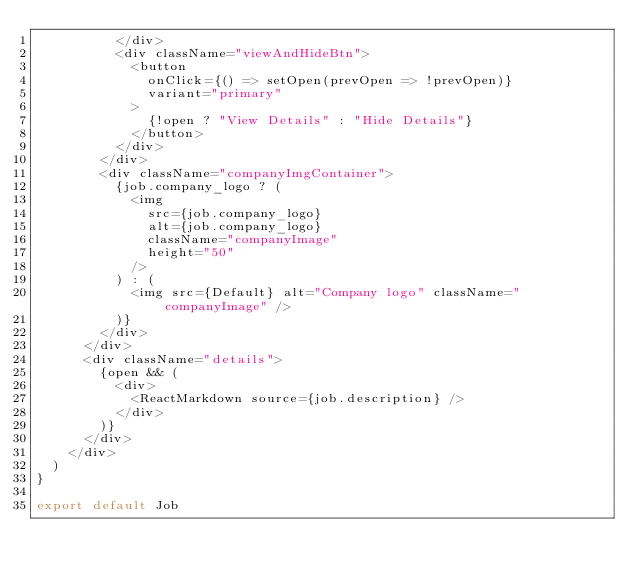Convert code to text. <code><loc_0><loc_0><loc_500><loc_500><_JavaScript_>          </div>
          <div className="viewAndHideBtn">
            <button
              onClick={() => setOpen(prevOpen => !prevOpen)}
              variant="primary"
            >
              {!open ? "View Details" : "Hide Details"}
            </button>
          </div>
        </div>
        <div className="companyImgContainer">
          {job.company_logo ? (
            <img
              src={job.company_logo}
              alt={job.company_logo}
              className="companyImage"
              height="50"
            />
          ) : (
            <img src={Default} alt="Company logo" className="companyImage" />
          )}
        </div>
      </div>
      <div className="details">
        {open && (
          <div>
            <ReactMarkdown source={job.description} />
          </div>
        )}
      </div>
    </div>
  )
}

export default Job
</code> 